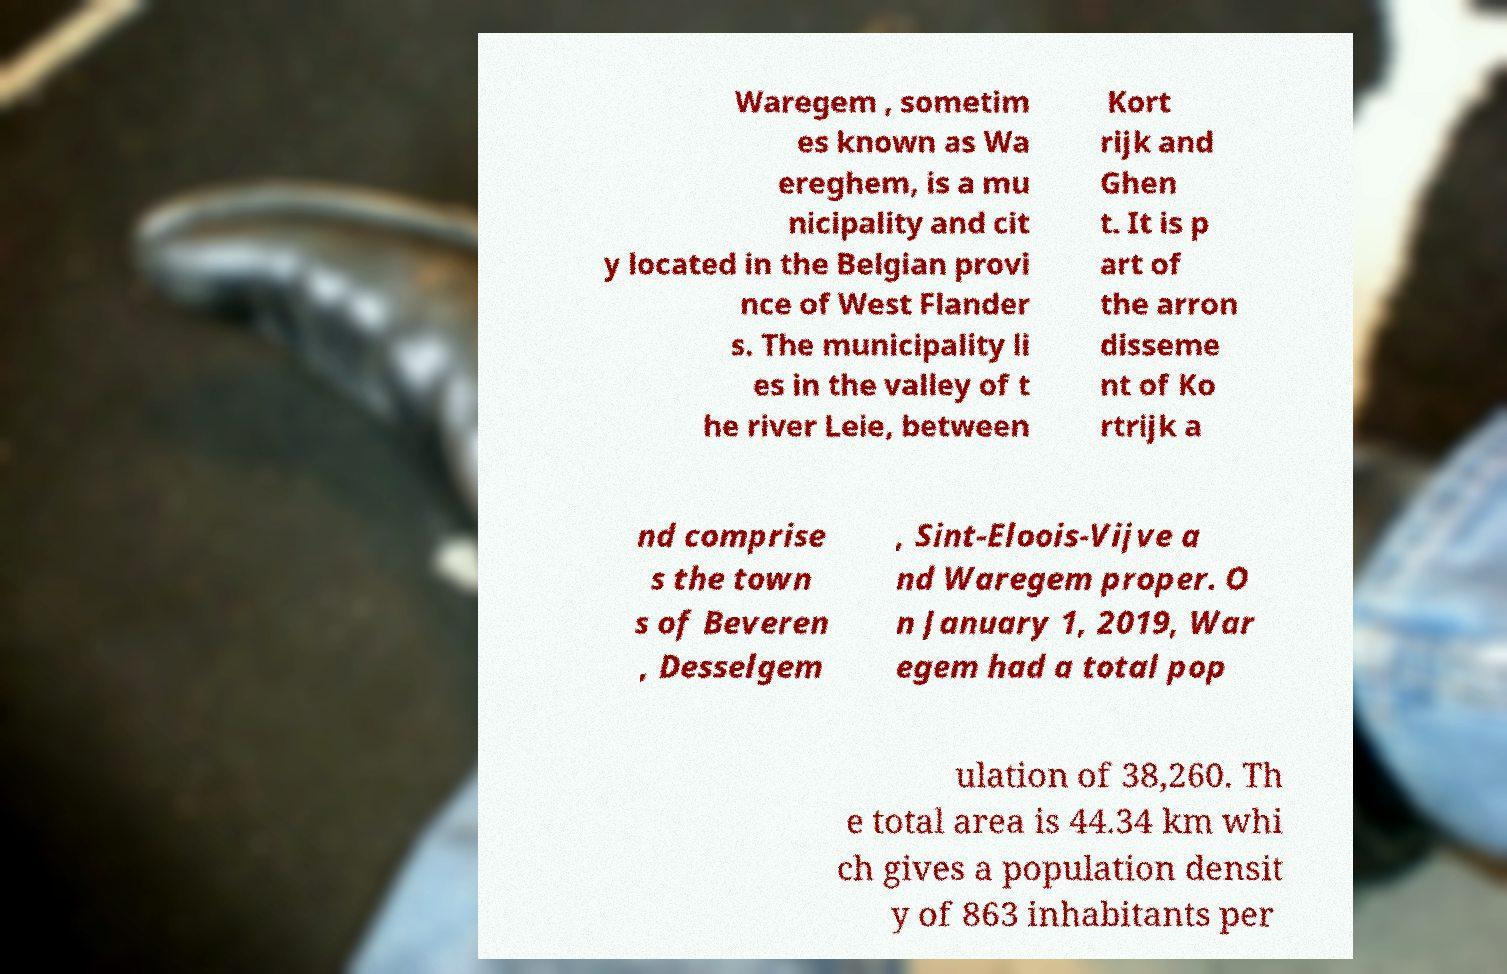Please identify and transcribe the text found in this image. Waregem , sometim es known as Wa ereghem, is a mu nicipality and cit y located in the Belgian provi nce of West Flander s. The municipality li es in the valley of t he river Leie, between Kort rijk and Ghen t. It is p art of the arron disseme nt of Ko rtrijk a nd comprise s the town s of Beveren , Desselgem , Sint-Eloois-Vijve a nd Waregem proper. O n January 1, 2019, War egem had a total pop ulation of 38,260. Th e total area is 44.34 km whi ch gives a population densit y of 863 inhabitants per 